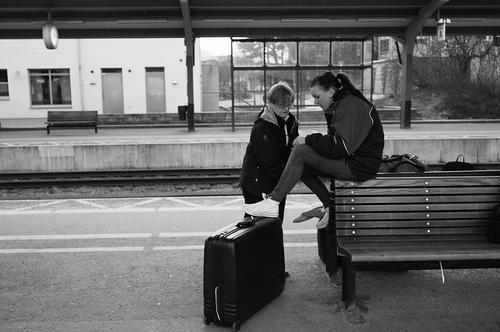How many people are in the picture?
Give a very brief answer. 2. 